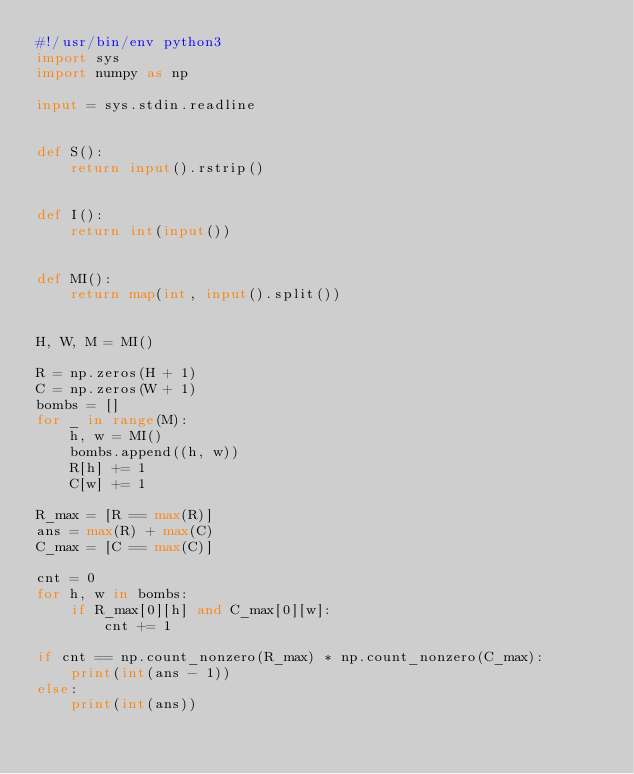Convert code to text. <code><loc_0><loc_0><loc_500><loc_500><_Python_>#!/usr/bin/env python3
import sys
import numpy as np

input = sys.stdin.readline


def S():
    return input().rstrip()


def I():
    return int(input())


def MI():
    return map(int, input().split())


H, W, M = MI()

R = np.zeros(H + 1)
C = np.zeros(W + 1)
bombs = []
for _ in range(M):
    h, w = MI()
    bombs.append((h, w))
    R[h] += 1
    C[w] += 1

R_max = [R == max(R)]
ans = max(R) + max(C)
C_max = [C == max(C)]

cnt = 0
for h, w in bombs:
    if R_max[0][h] and C_max[0][w]:
        cnt += 1

if cnt == np.count_nonzero(R_max) * np.count_nonzero(C_max):
    print(int(ans - 1))
else:
    print(int(ans))
</code> 